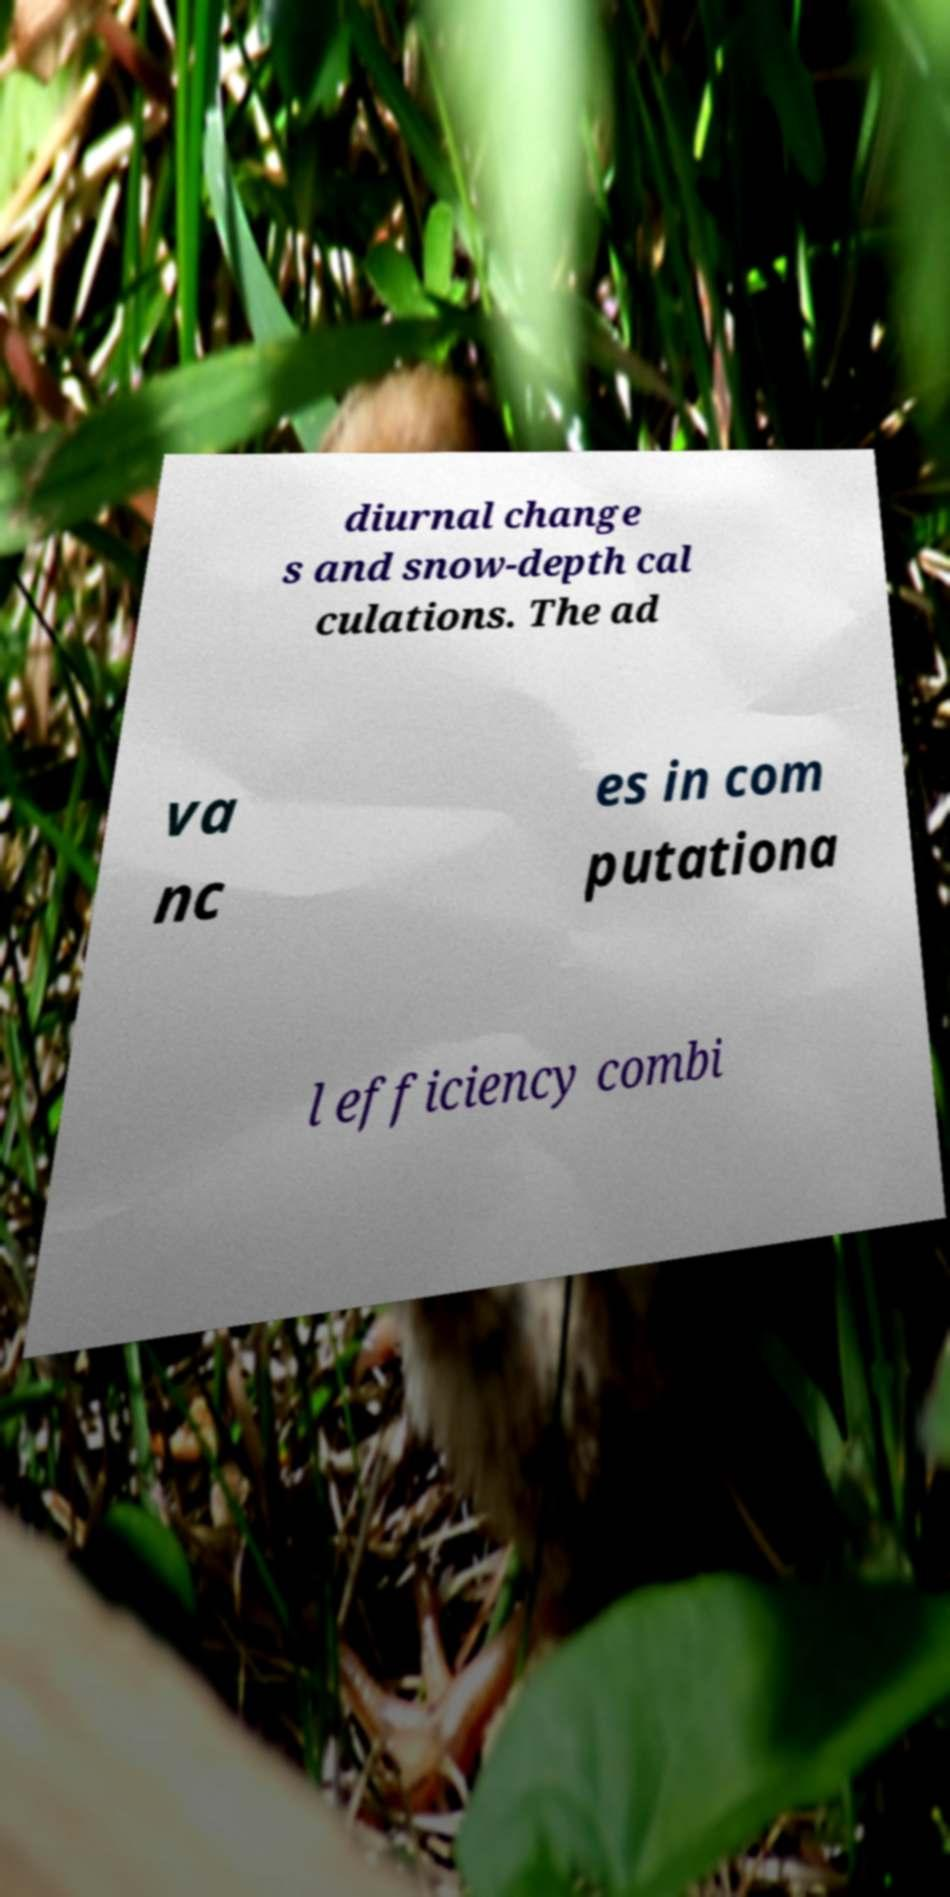Could you extract and type out the text from this image? diurnal change s and snow-depth cal culations. The ad va nc es in com putationa l efficiency combi 